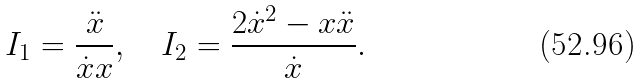<formula> <loc_0><loc_0><loc_500><loc_500>I _ { 1 } = \frac { \ddot { x } } { \dot { x } x } , \quad I _ { 2 } = \frac { 2 \dot { x } ^ { 2 } - x \ddot { x } } { \dot { x } } .</formula> 